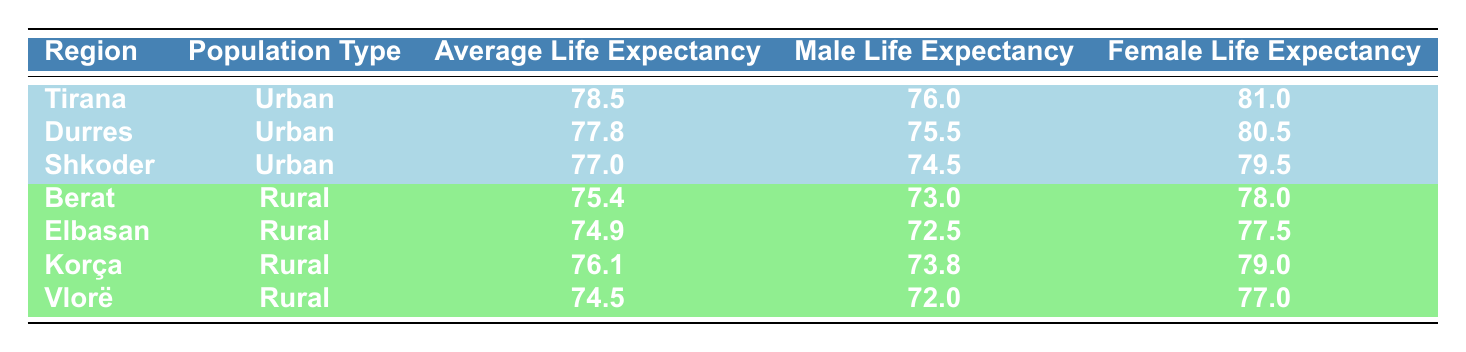What is the average life expectancy for urban populations in Albania? The average life expectancy for urban populations can be calculated by taking the average of the average life expectancies listed for Tirana, Durres, and Shkoder. Adding these gives (78.5 + 77.8 + 77.0) = 233.3, and dividing by 3 results in an average of 77.8.
Answer: 77.8 What is the average life expectancy for rural populations in Albania? The average life expectancy for rural populations can be determined by averaging the values for Berat, Elbasan, Korça, and Vlorë. Summing these values (75.4 + 74.9 + 76.1 + 74.5) equals 301. Such data averaged over the four regions gives 301/4 = 75.25.
Answer: 75.25 Is the male life expectancy higher in Tirana than in Berat? To determine this, we compare the male life expectancies: Tirana has a male life expectancy of 76.0, while Berat has a male life expectancy of 73.0. Since 76.0 is greater than 73.0, the statement is true.
Answer: Yes Which region has the highest female life expectancy? Referring to the table, Tirana has the highest female life expectancy at 81.0. We then check the female life expectancy in other regions: Durres (80.5), Shkoder (79.5), Berat (78.0), Elbasan (77.5), Korça (79.0), and Vlorë (77.0). Since 81.0 from Tirana is the highest, the answer is confirmed.
Answer: Tirana What is the difference in average life expectancy between urban and rural populations in Albania? We first calculate the average life expectancy for urban populations as 77.8 and for rural as 75.25 as calculated earlier. The difference is computed by subtracting the rural average from the urban average: 77.8 - 75.25 = 2.55.
Answer: 2.55 Is the average male life expectancy in rural areas higher than in urban areas? We first check the averages: the average male life expectancy for urban areas is (76.0 + 75.5 + 74.5) / 3 = 75.67, and for rural areas, it's (73.0 + 72.5 + 73.8 + 72.0) / 4 = 72.83. Since 75.67 is greater than 72.83, the statement is false.
Answer: No What percentage of the regions listed are urban? There are a total of 7 regions, 3 of which are urban (Tirana, Durres, Shkoder). Therefore, to find the percentage, we calculate (3 / 7) * 100, which equals approximately 42.86%.
Answer: 42.86% Which population type has a higher average life expectancy for females? We compare the female life expectancy averages: urban females average 80.5 (Durres) and 81.0 (Tirana) and rural females average 78.0 (Berat) and 77.5 (Elbasan), with Korça (79.0) and Vlorë (77.0) also considered, leading to an average of about 75.25 in rural and 79.5 in urban. Since urban averages (80.5, 81.0) are higher, the urban population has the higher expectancy.
Answer: Urban 